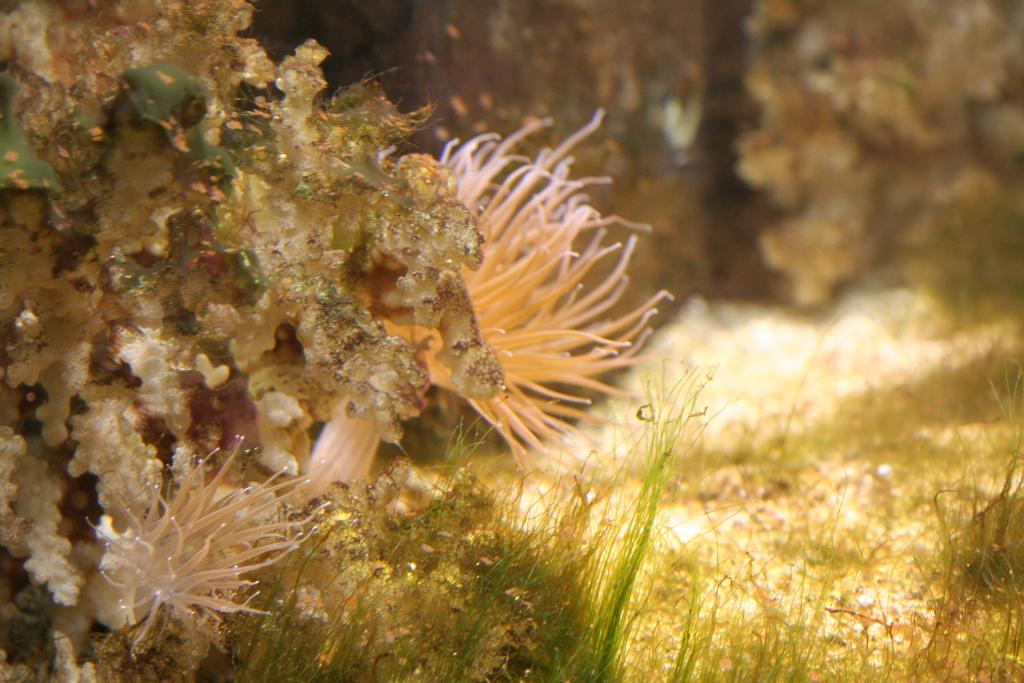What type of living organisms can be seen in the image? Plants can be seen in the image. Can you describe the background of the image? The background of the image is blurry. What channel is the river flowing through in the image? There is no river or channel present in the image; it features plants and a blurry background. 